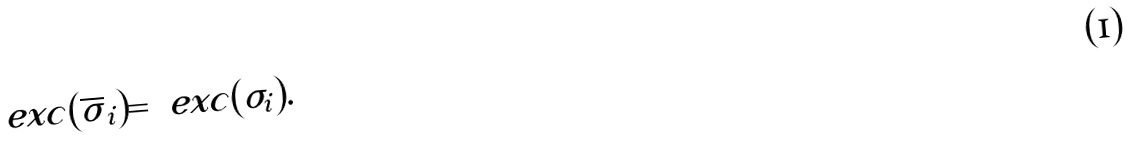Convert formula to latex. <formula><loc_0><loc_0><loc_500><loc_500>\ e x c ( \overline { \sigma } _ { i } ) = \ e x c ( \sigma _ { i } ) .</formula> 